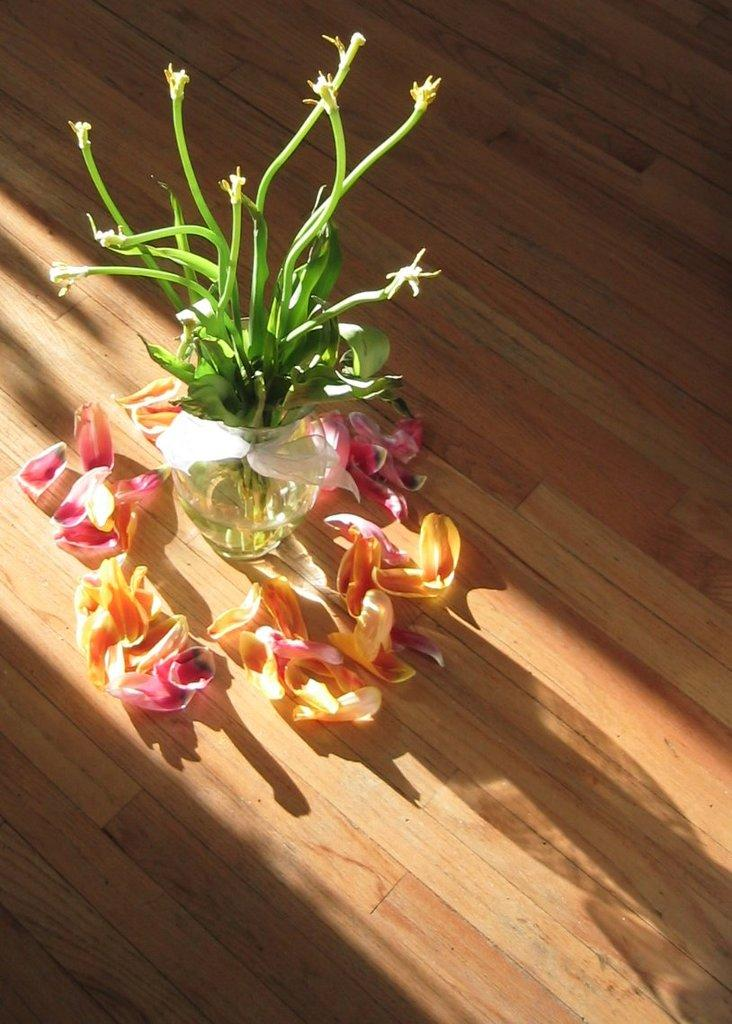What object is present in the image that holds flowers? There is a flower vase in the image. What is inside the flower vase? There are flowers in the image. Where are the flower vase and flowers located? The flower vase and flowers are placed on the floor. Is there a goldfish swimming in the flower vase in the image? No, there is no goldfish present in the image. The image only features a flower vase and flowers placed on the floor. 